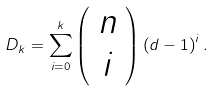<formula> <loc_0><loc_0><loc_500><loc_500>D _ { k } = \sum _ { i = 0 } ^ { k } \left ( \begin{array} { c c c } n \\ i \end{array} \right ) \left ( d - 1 \right ) ^ { i } .</formula> 